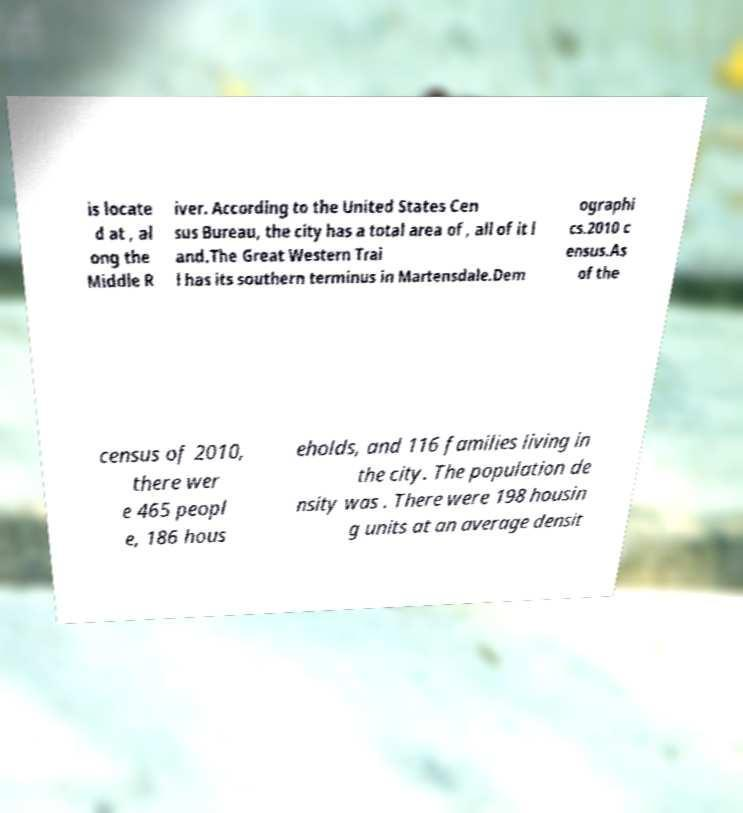I need the written content from this picture converted into text. Can you do that? is locate d at , al ong the Middle R iver. According to the United States Cen sus Bureau, the city has a total area of , all of it l and.The Great Western Trai l has its southern terminus in Martensdale.Dem ographi cs.2010 c ensus.As of the census of 2010, there wer e 465 peopl e, 186 hous eholds, and 116 families living in the city. The population de nsity was . There were 198 housin g units at an average densit 